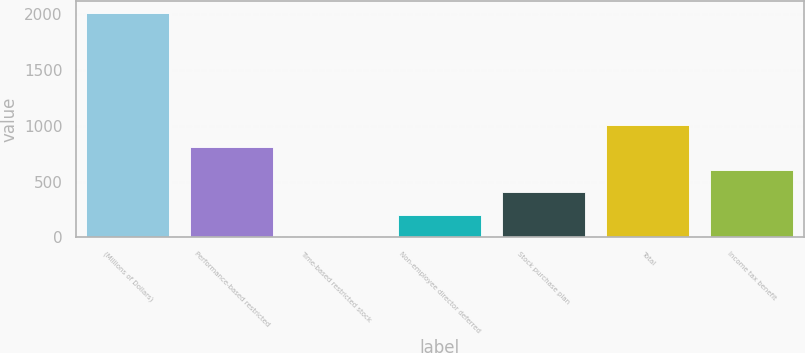Convert chart. <chart><loc_0><loc_0><loc_500><loc_500><bar_chart><fcel>(Millions of Dollars)<fcel>Performance-based restricted<fcel>Time-based restricted stock<fcel>Non-employee director deferred<fcel>Stock purchase plan<fcel>Total<fcel>Income tax benefit<nl><fcel>2015<fcel>806.6<fcel>1<fcel>202.4<fcel>403.8<fcel>1008<fcel>605.2<nl></chart> 